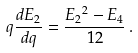Convert formula to latex. <formula><loc_0><loc_0><loc_500><loc_500>q \frac { d E _ { 2 } } { d q } = \frac { { E _ { 2 } } ^ { 2 } - E _ { 4 } } { 1 2 } \, .</formula> 